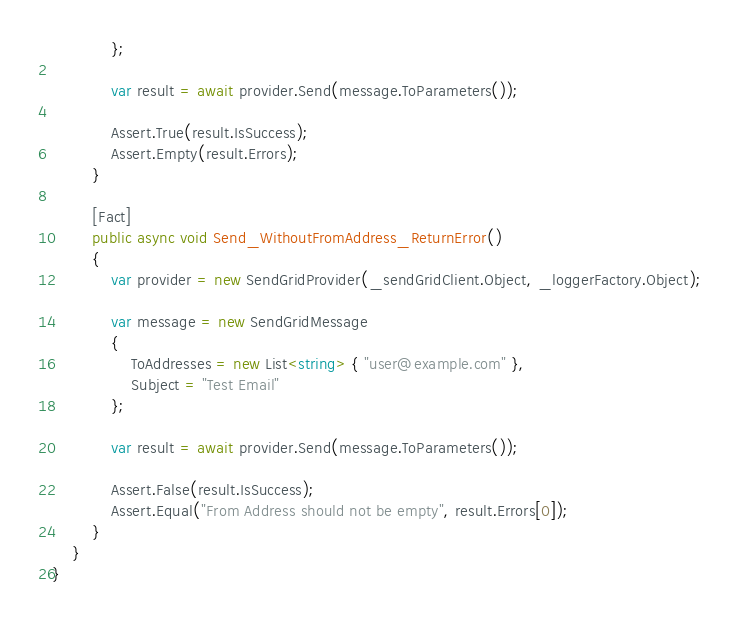Convert code to text. <code><loc_0><loc_0><loc_500><loc_500><_C#_>            };

            var result = await provider.Send(message.ToParameters());

            Assert.True(result.IsSuccess);
            Assert.Empty(result.Errors);
        }

        [Fact]
        public async void Send_WithoutFromAddress_ReturnError()
        {
            var provider = new SendGridProvider(_sendGridClient.Object, _loggerFactory.Object);

            var message = new SendGridMessage
            {
                ToAddresses = new List<string> { "user@example.com" },
                Subject = "Test Email"
            };

            var result = await provider.Send(message.ToParameters());

            Assert.False(result.IsSuccess);
            Assert.Equal("From Address should not be empty", result.Errors[0]);
        }
    }
}
</code> 